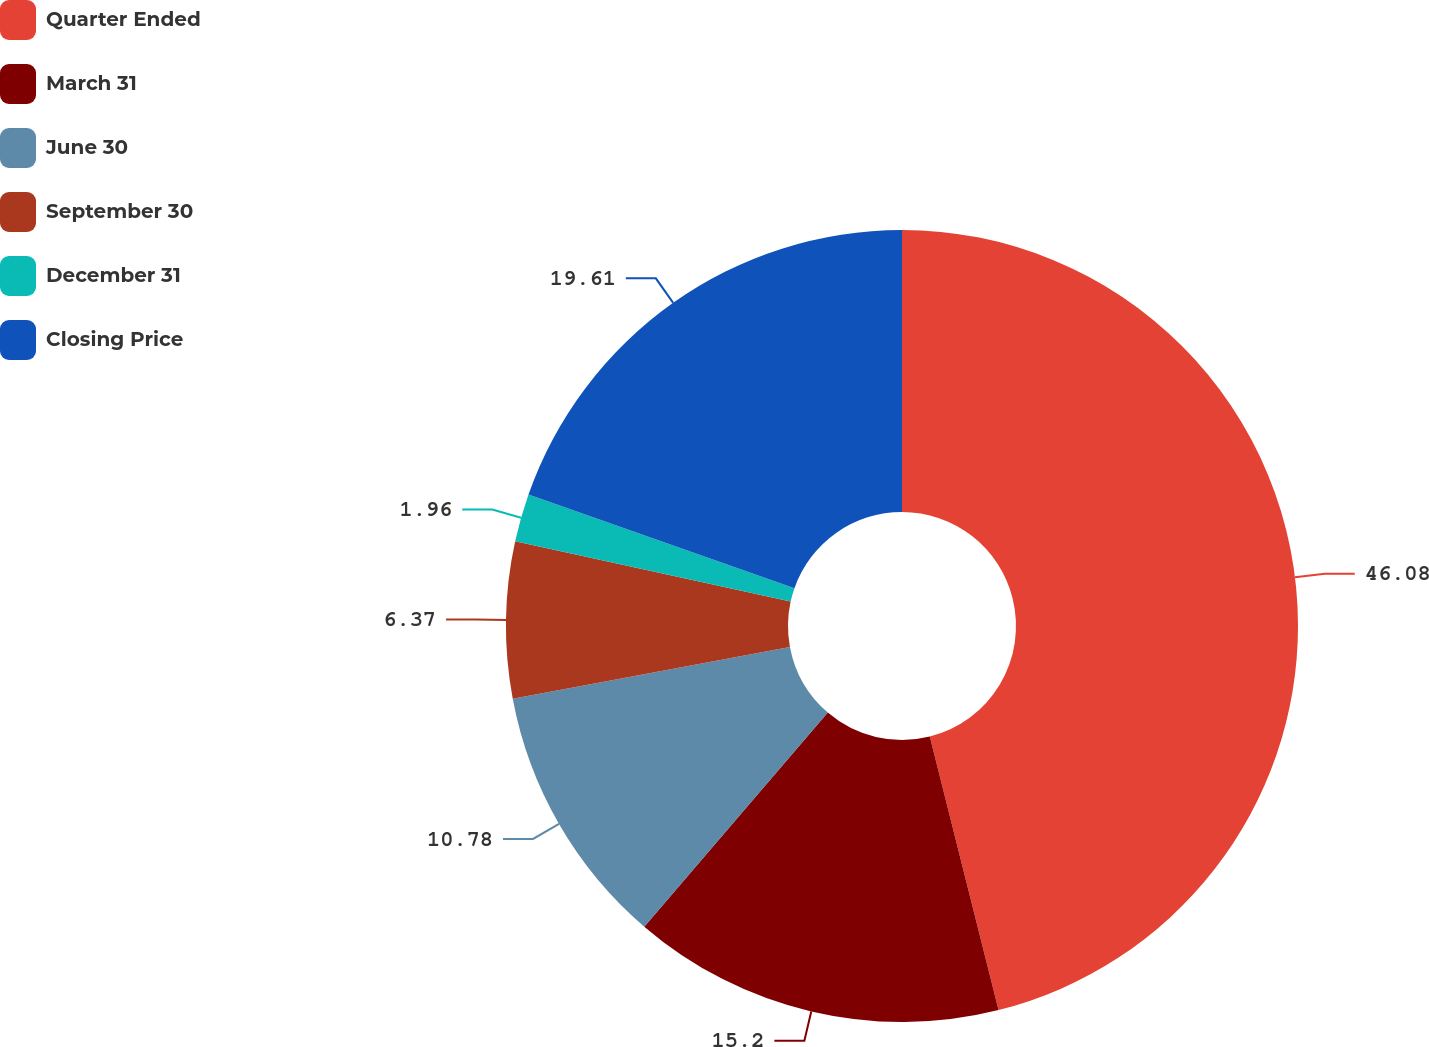Convert chart to OTSL. <chart><loc_0><loc_0><loc_500><loc_500><pie_chart><fcel>Quarter Ended<fcel>March 31<fcel>June 30<fcel>September 30<fcel>December 31<fcel>Closing Price<nl><fcel>46.08%<fcel>15.2%<fcel>10.78%<fcel>6.37%<fcel>1.96%<fcel>19.61%<nl></chart> 